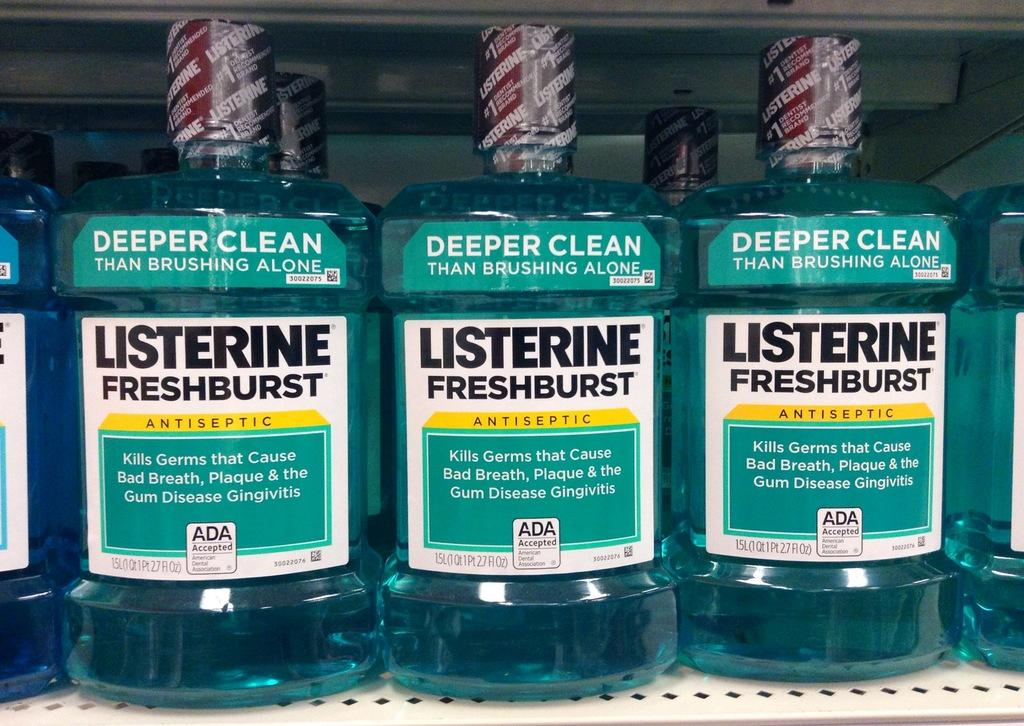<image>
Render a clear and concise summary of the photo. Three bottles of liquid with the word Listerine on it 